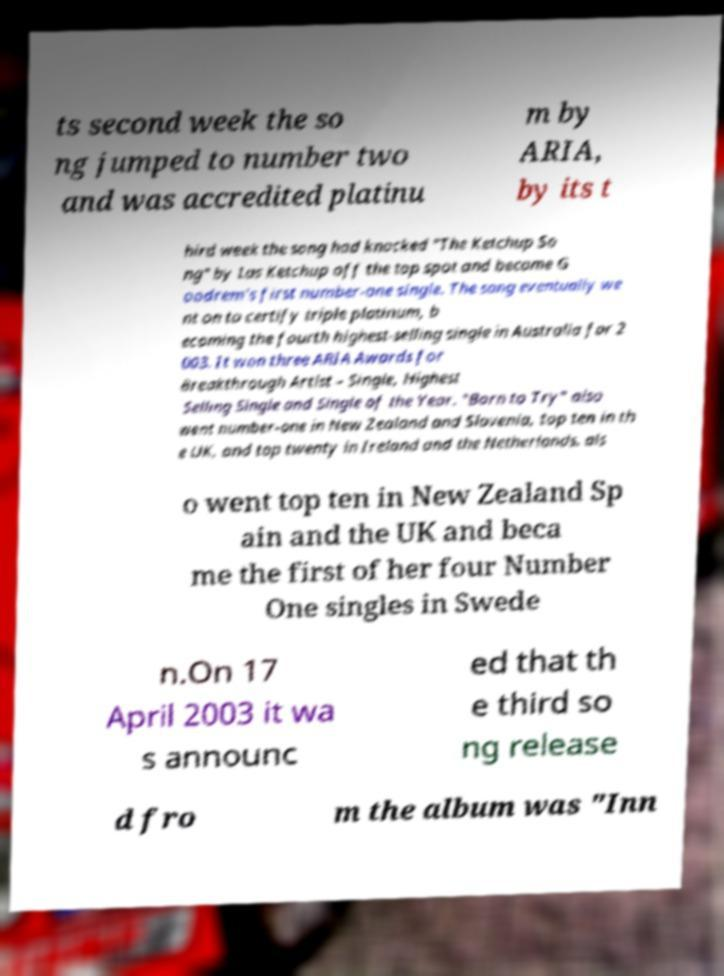Please read and relay the text visible in this image. What does it say? ts second week the so ng jumped to number two and was accredited platinu m by ARIA, by its t hird week the song had knocked "The Ketchup So ng" by Las Ketchup off the top spot and became G oodrem's first number-one single. The song eventually we nt on to certify triple platinum, b ecoming the fourth highest-selling single in Australia for 2 003. It won three ARIA Awards for Breakthrough Artist – Single, Highest Selling Single and Single of the Year. "Born to Try" also went number-one in New Zealand and Slovenia, top ten in th e UK, and top twenty in Ireland and the Netherlands. als o went top ten in New Zealand Sp ain and the UK and beca me the first of her four Number One singles in Swede n.On 17 April 2003 it wa s announc ed that th e third so ng release d fro m the album was "Inn 